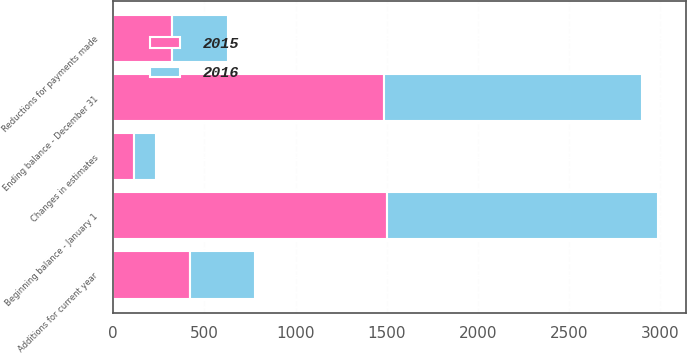Convert chart to OTSL. <chart><loc_0><loc_0><loc_500><loc_500><stacked_bar_chart><ecel><fcel>Beginning balance - January 1<fcel>Additions for current year<fcel>Reductions for payments made<fcel>Changes in estimates<fcel>Ending balance - December 31<nl><fcel>2016<fcel>1485<fcel>356<fcel>309<fcel>118<fcel>1414<nl><fcel>2015<fcel>1504<fcel>421<fcel>323<fcel>117<fcel>1485<nl></chart> 